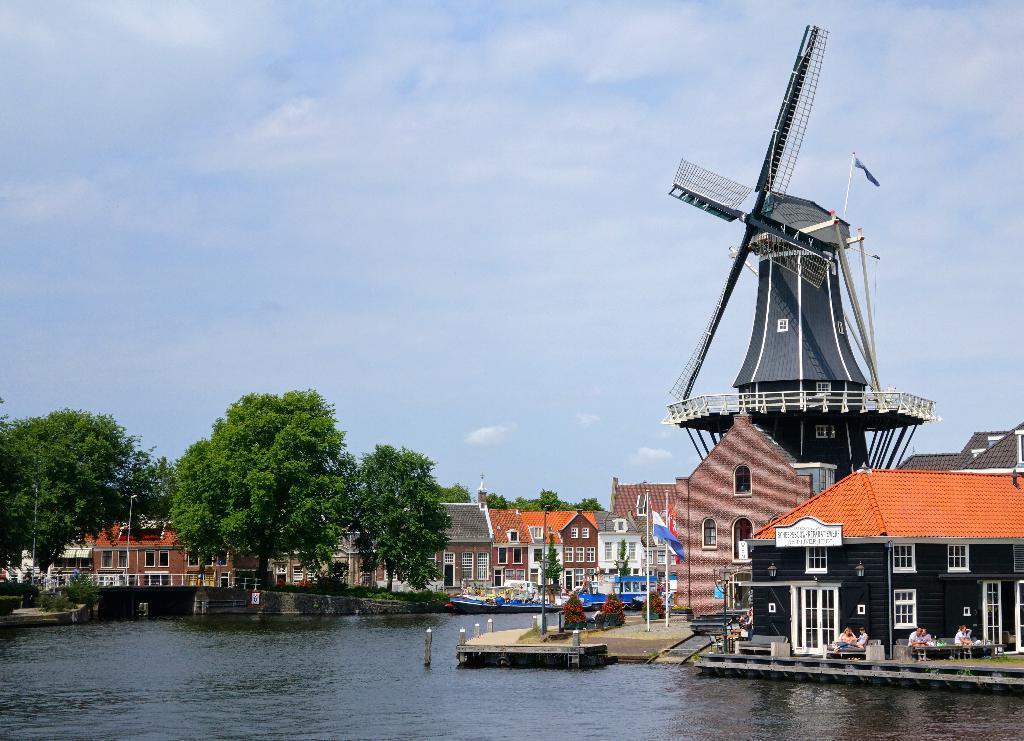Describe this image in one or two sentences. In this picture there is water at the bottom side of the image and there is dock at the bottom side of the image and there are houses and trees in the center of the image and there is wind mill on the right side of the image, there is sky at the top side of the image, there are people on the dock. 